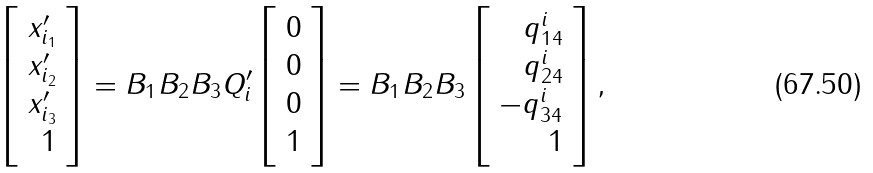<formula> <loc_0><loc_0><loc_500><loc_500>\left [ \begin{array} { r } x _ { i _ { 1 } } ^ { \prime } \\ x _ { i _ { 2 } } ^ { \prime } \\ x _ { i _ { 3 } } ^ { \prime } \\ 1 \end{array} \right ] = B _ { 1 } B _ { 2 } B _ { 3 } Q _ { i } ^ { \prime } \left [ \begin{array} { r } 0 \\ 0 \\ 0 \\ 1 \end{array} \right ] = B _ { 1 } B _ { 2 } B _ { 3 } \left [ \begin{array} { r } q _ { 1 4 } ^ { i } \\ q _ { 2 4 } ^ { i } \\ - q _ { 3 4 } ^ { i } \\ 1 \end{array} \right ] ,</formula> 